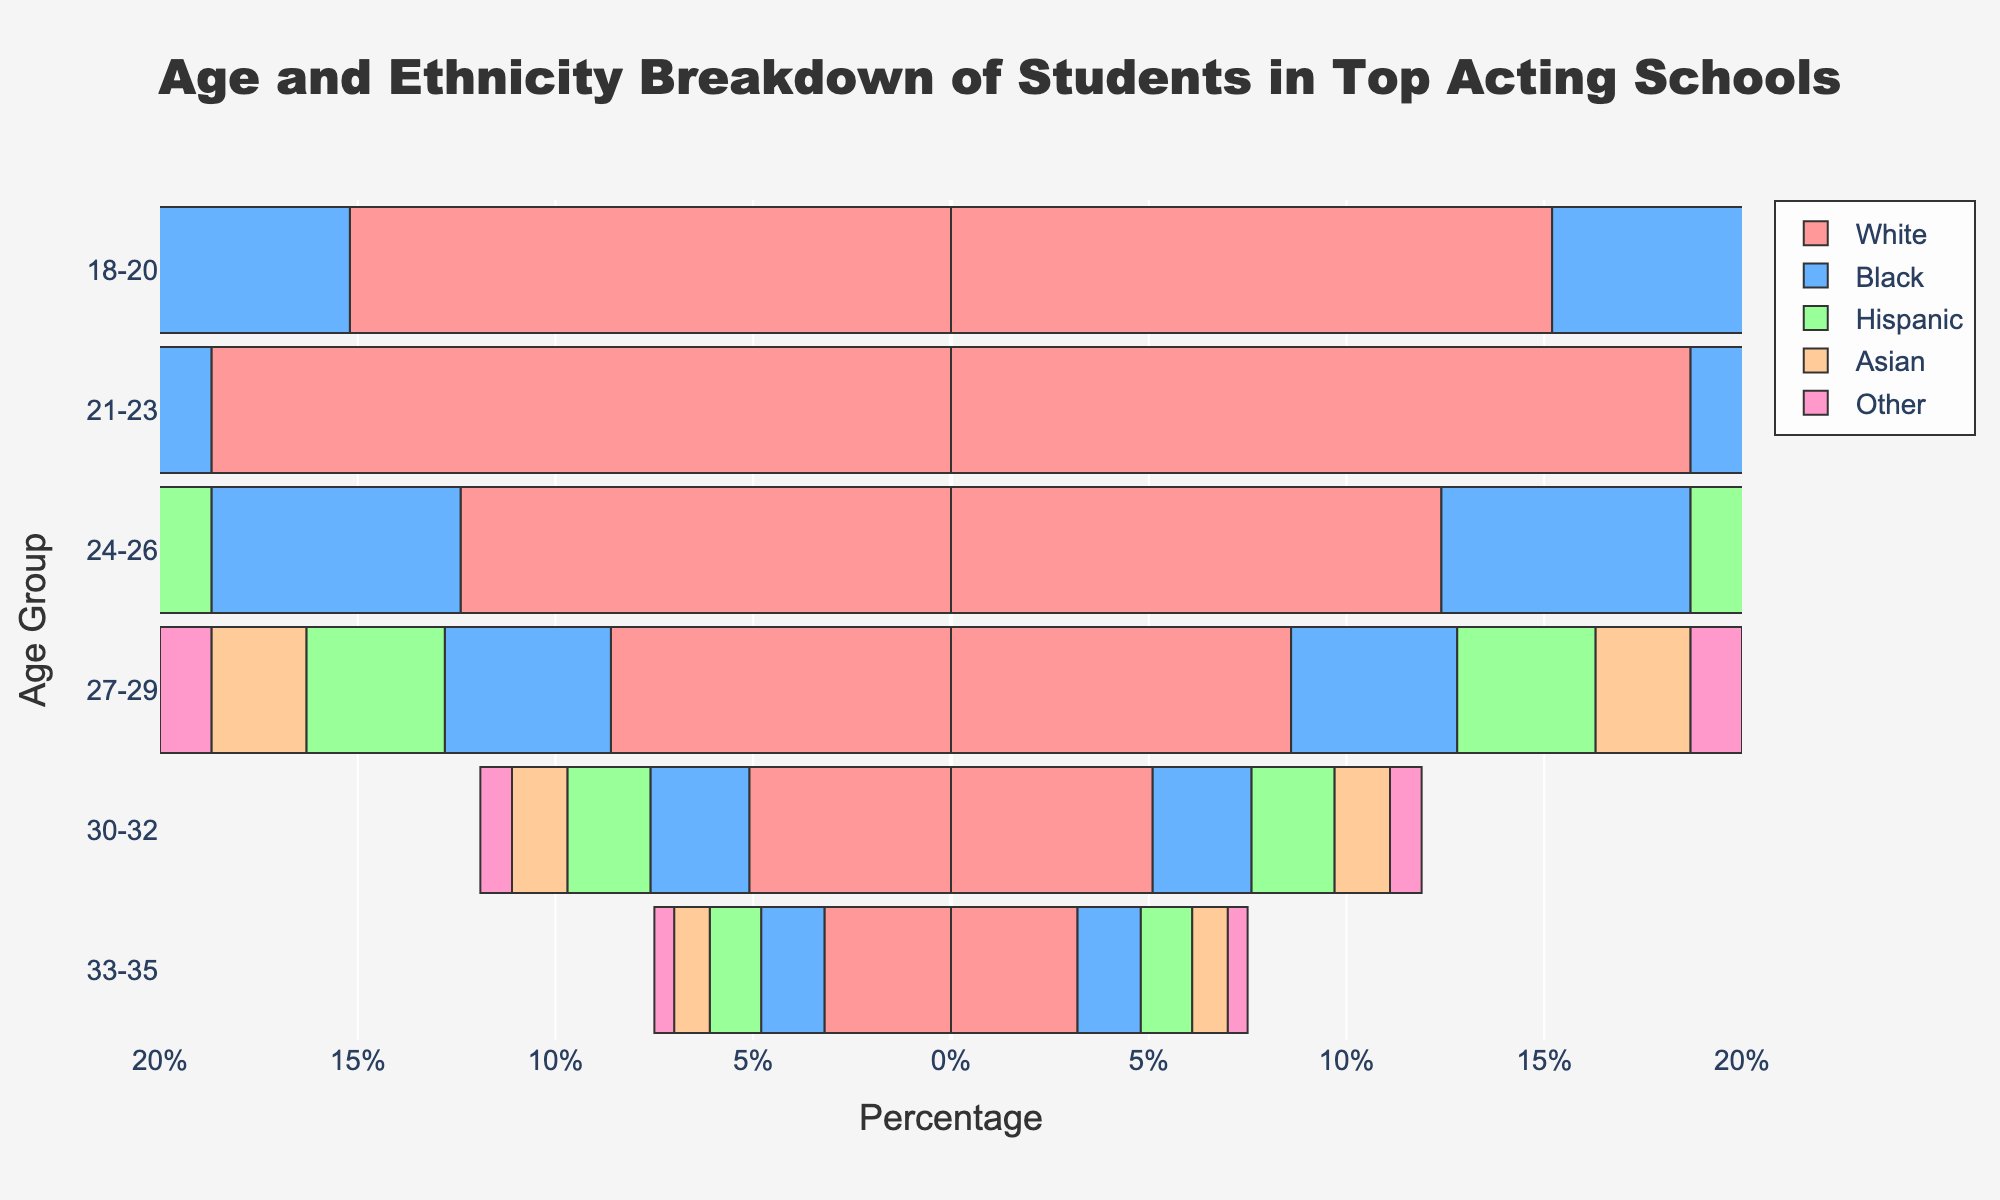what is the percentage of White students in the age group 21-23? Look at the bar corresponding to the age group 21-23 and find the value for White ethnicity.
Answer: 18.7% what is the combined percentage of Asian students in the age groups 24-26 and 27-29? Find the percentages of Asian students in the two age groups and add them up: 3.6% + 2.4%.
Answer: 6.0% Which age group has the highest percentage of Hispanic students? Compare the values of Hispanic students across all age groups and find the highest value.
Answer: 21-23 How does the percentage of Black students change from the age group 18-20 to 21-23? Subtract the percentage of Black students in the age group 18-20 from the percentage in the age group 21-23: 9.1% - 7.8%.
Answer: Increases by 1.3% Which ethnicity shows the most significant decrease in percentage as age increases from 18-20 to 33-35? Evaluate the decline for each ethnicity from the youngest to the oldest age group.
Answer: White In the age group 30-32, do Hispanic students make up a larger percentage than students of Asian ethnicity? Compare the percentage values of Hispanic and Asian students in the age group 30-32.
Answer: Yes What is the total percentage of students aged 18-20 across all ethnicities? Add the percentages of all ethnic groups for the age group 18-20: 15.2 + 7.8 + 6.5 + 4.2 + 2.3.
Answer: 36.0% What is the percentage difference between the highest and the lowest ethnic group in the age range 27-29? Identify the highest percentage (White: 8.6%) and the lowest (Other: 1.3%) and subtract the latter from the former: 8.6% - 1.3%.
Answer: 7.3% How does the representation of students listed as 'Other' ethnicities compare between the age groups 18-20 and 33-35? Compare the percentages of 'Other' ethnicities in the two age groups (2.3% for 18-20 and 0.5% for 33-35).
Answer: Decreases What age group has the lowest representation for students of 'Asian' ethnicity? Find the minimum percentage for the Asian category across all age groups.
Answer: 33-35 